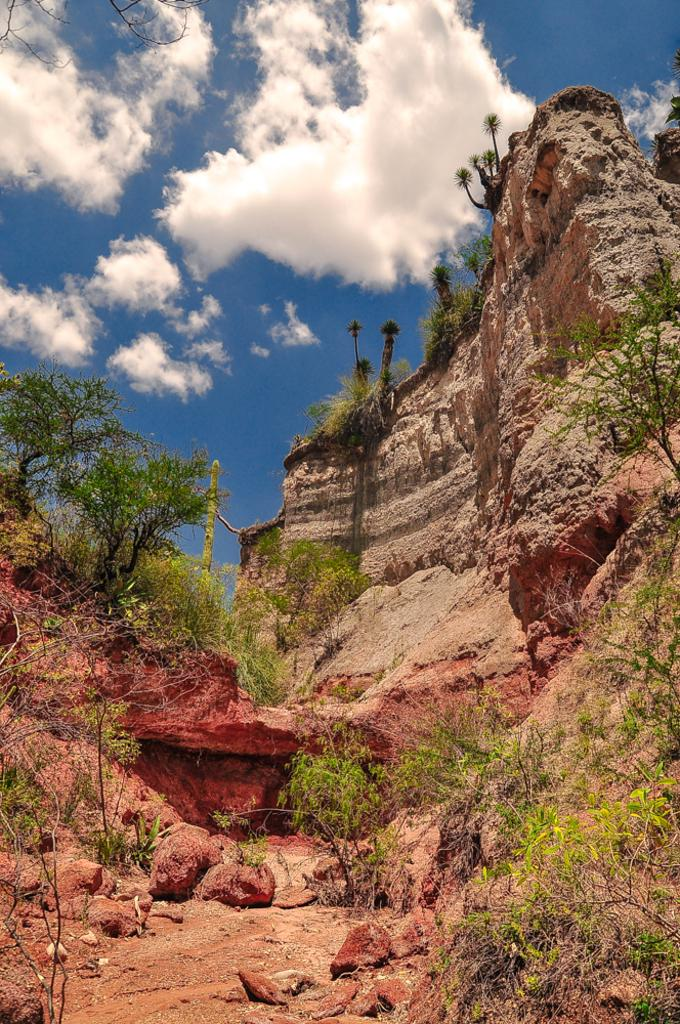What type of landscape is depicted in the image? The image appears to depict a hill. What type of vegetation can be seen in the image? There are trees and plants in the image. What type of geological features are present in the image? There are rocks in the image. What is visible in the sky at the top of the image? Clouds are visible in the sky at the top of the image. Can you tell me how many yaks are grazing on the hill in the image? There are no yaks present in the image; it depicts a hill with trees, plants, rocks, and clouds. What type of animal is sitting on the rock in the image? There is no animal sitting on the rock in the image; it only shows a hill with trees, plants, rocks, and clouds. 